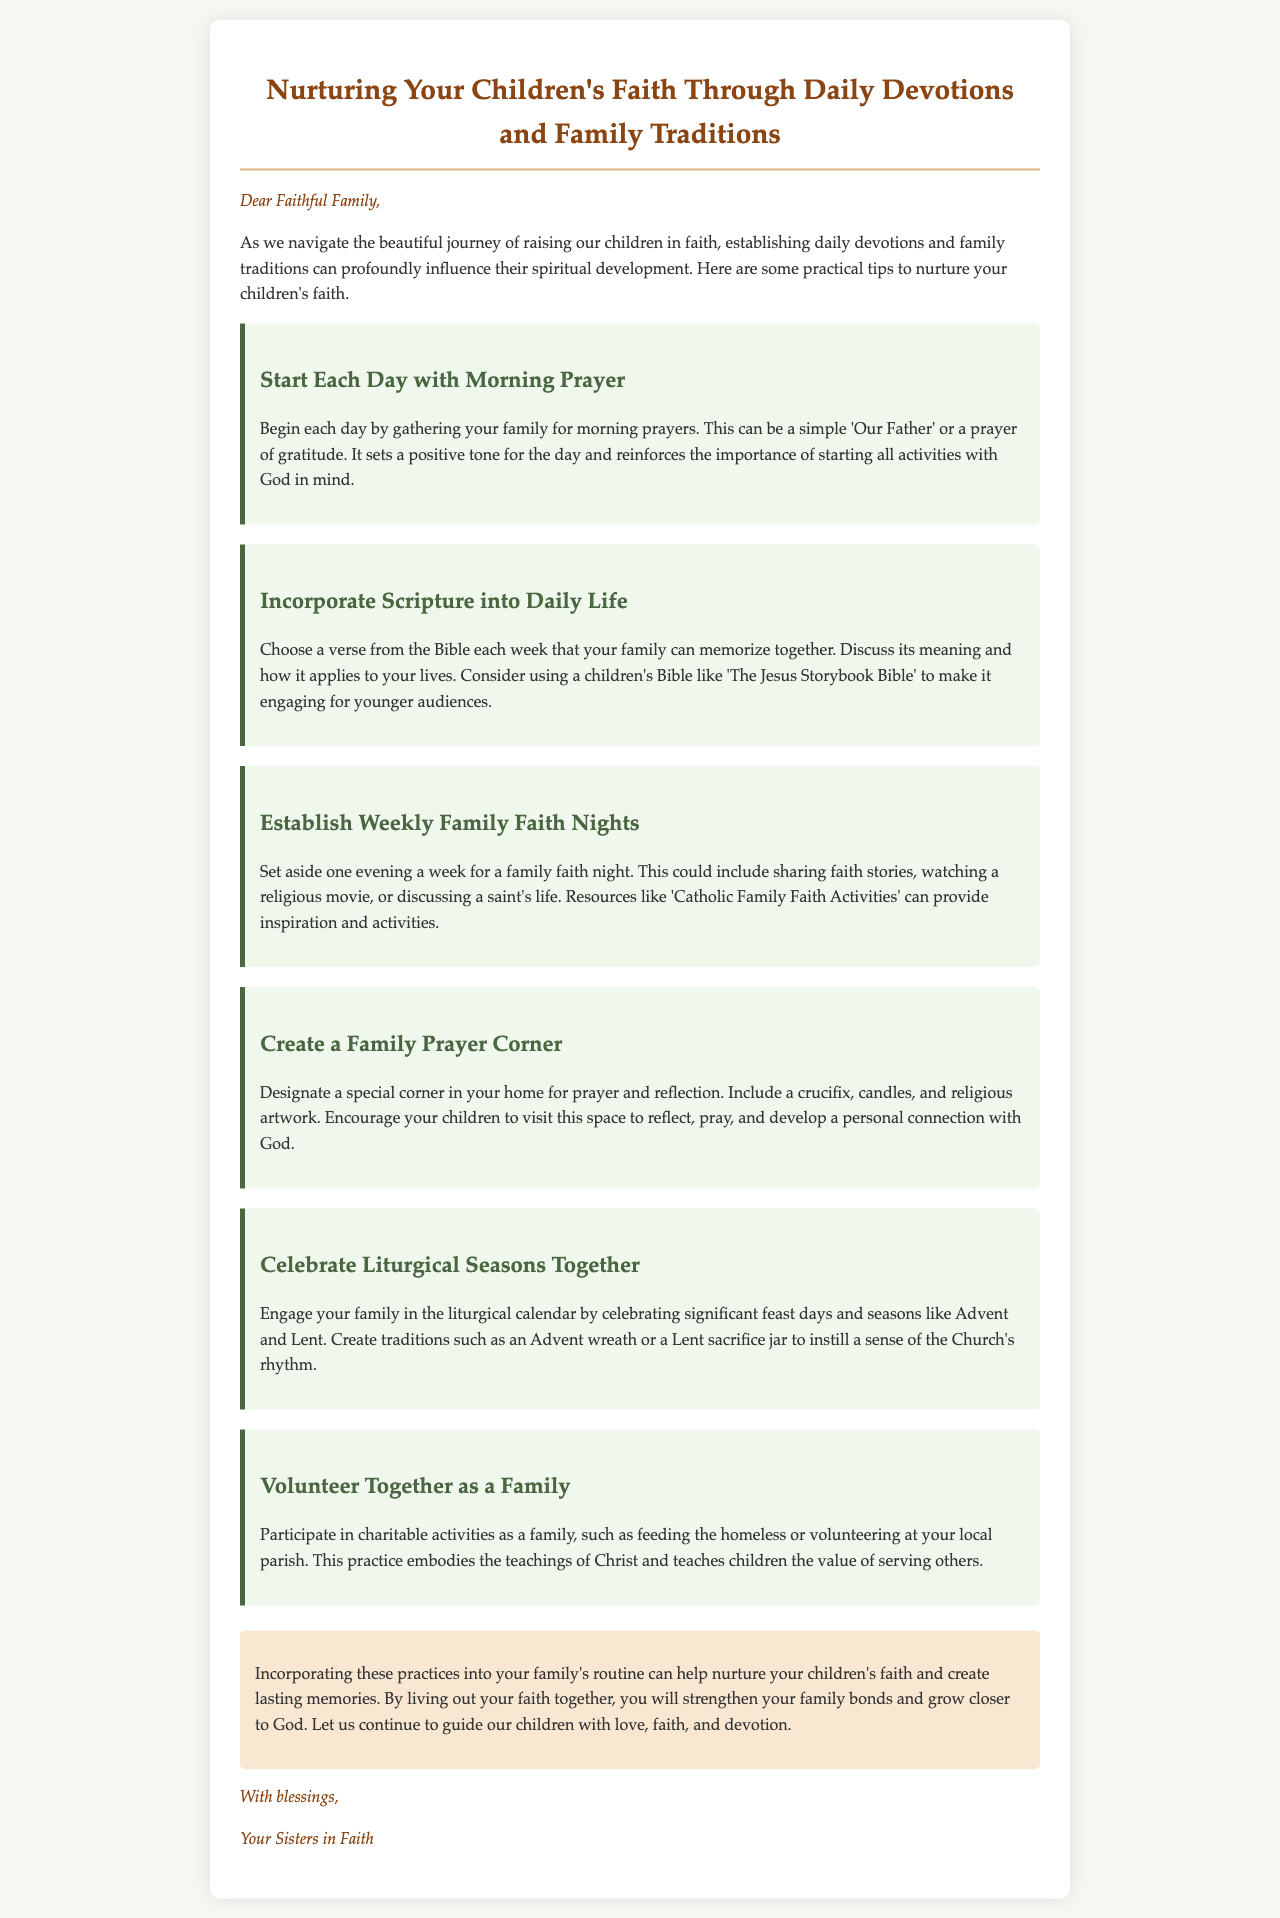What is the title of the document? The title is stated at the top of the document in a header format.
Answer: Nurturing Your Children's Faith Through Daily Devotions and Family Traditions Who is the greeting addressed to? The greeting introduces the recipients of the email.
Answer: Faithful Family What is suggested as a morning ritual? The document outlines a specific practice to start the day.
Answer: Morning Prayer What weekly activity is recommended for families? The document presents a specific gathering suggested for families to strengthen their faith.
Answer: Family Faith Nights What is one way to engage with Scripture mentioned in the document? The document explains a method for incorporating Scripture into daily life.
Answer: Memorize a verse Which liturgical seasons should families celebrate together? The document mentions specific times in the Christian calendar to observe.
Answer: Advent and Lent What is suggested to create in your home for prayer? The document refers to a specific space created for spiritual activities.
Answer: Family Prayer Corner How does the document recommend families embody Christ's teachings? The document contains advice on actions that reflect the teachings of Jesus.
Answer: Volunteering together 